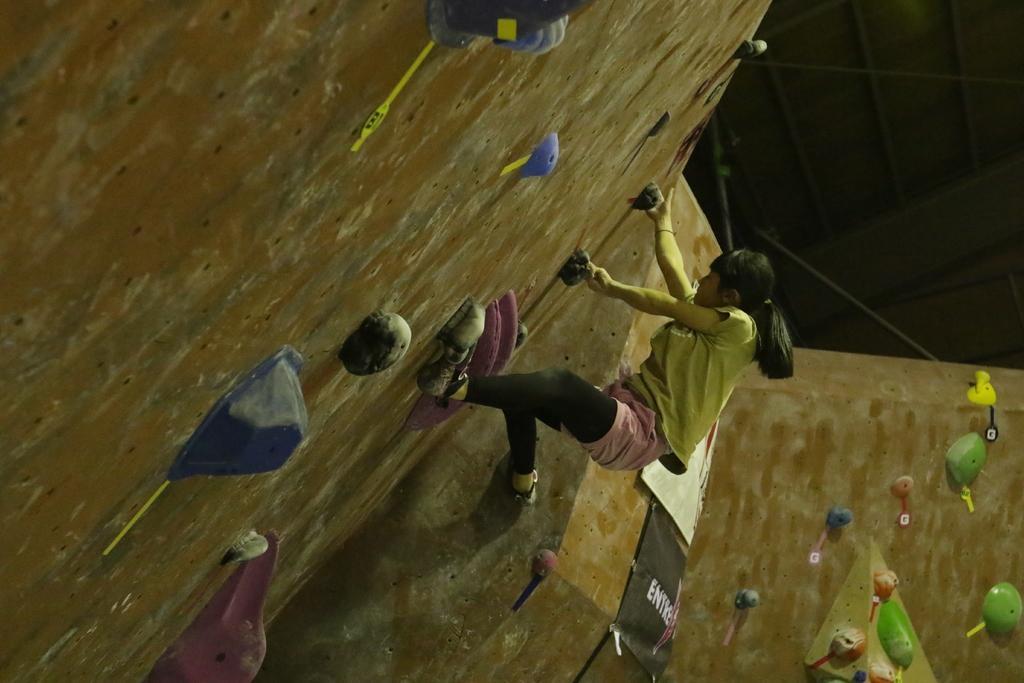In one or two sentences, can you explain what this image depicts? There is a woman in a t-shirt, climbing wall of a hill. And the background is dark in color. 